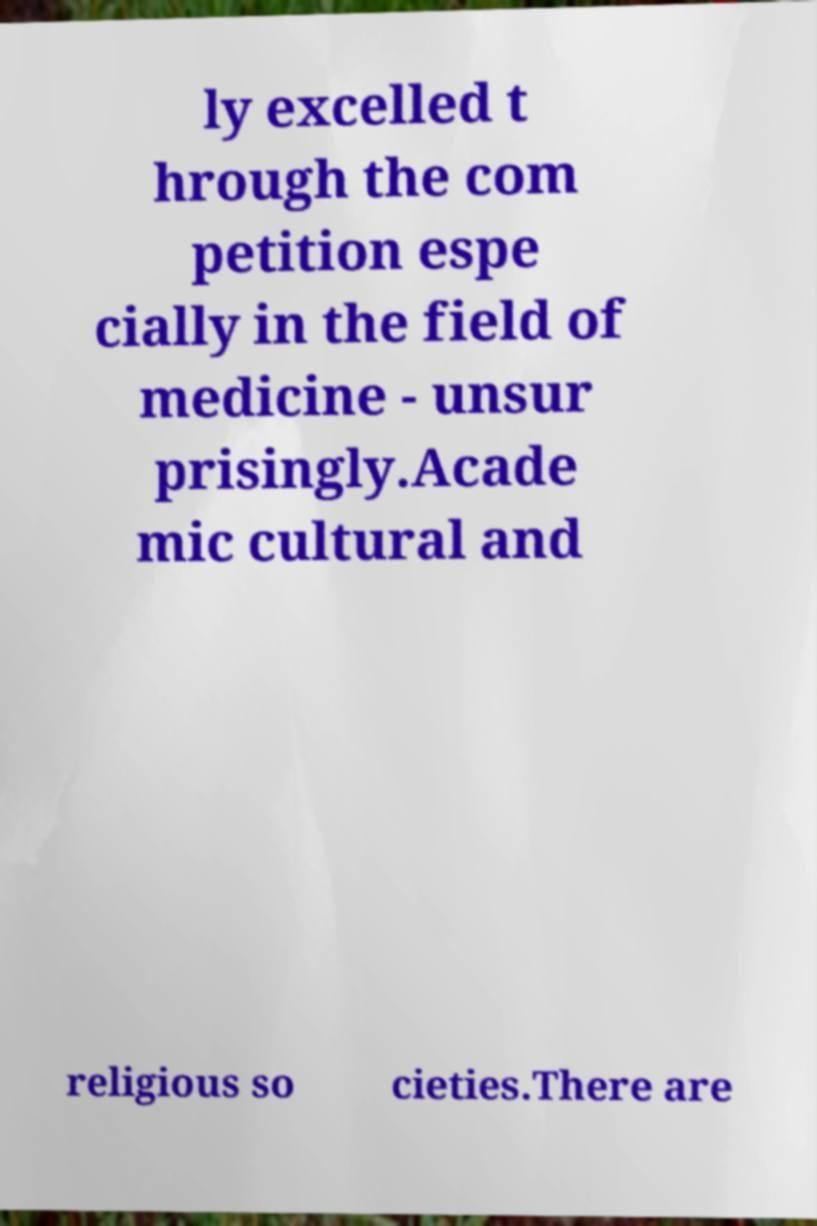Please read and relay the text visible in this image. What does it say? ly excelled t hrough the com petition espe cially in the field of medicine - unsur prisingly.Acade mic cultural and religious so cieties.There are 